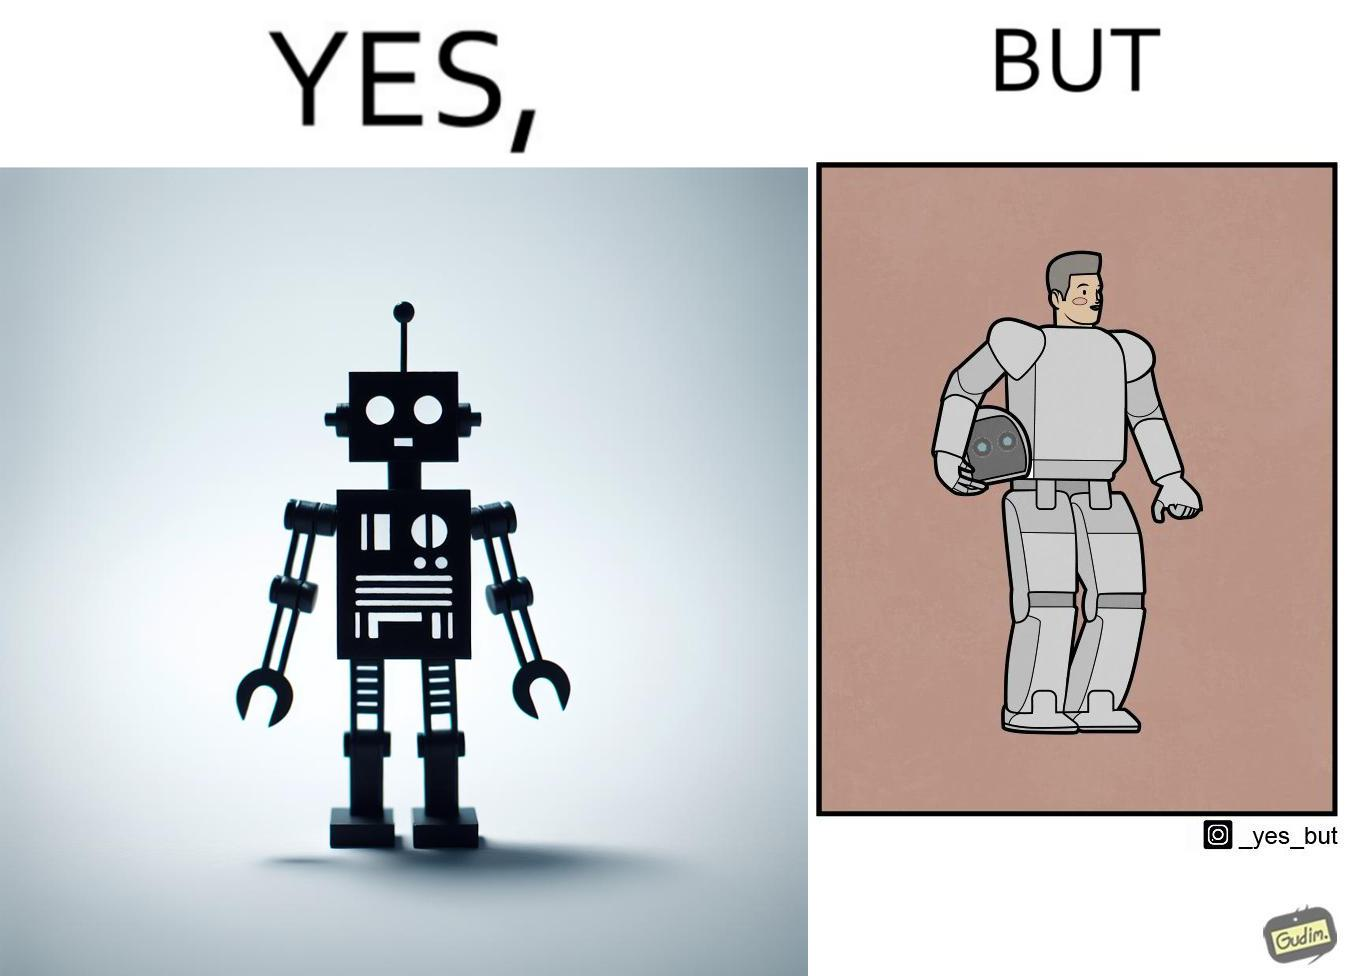Describe what you see in this image. The images are ironic since we work to improve technology and build innovations like robots, but in the process we ourselves become less human and robotic in the way we function. 